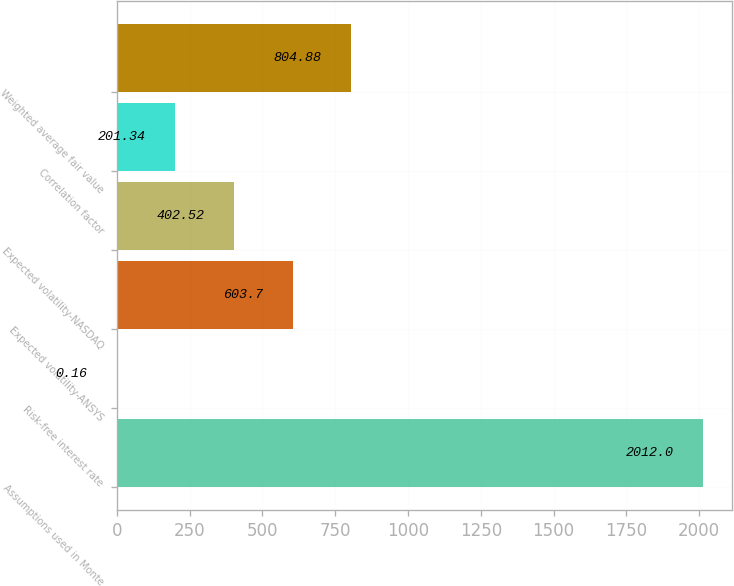Convert chart. <chart><loc_0><loc_0><loc_500><loc_500><bar_chart><fcel>Assumptions used in Monte<fcel>Risk-free interest rate<fcel>Expected volatility-ANSYS<fcel>Expected volatility-NASDAQ<fcel>Correlation factor<fcel>Weighted average fair value<nl><fcel>2012<fcel>0.16<fcel>603.7<fcel>402.52<fcel>201.34<fcel>804.88<nl></chart> 